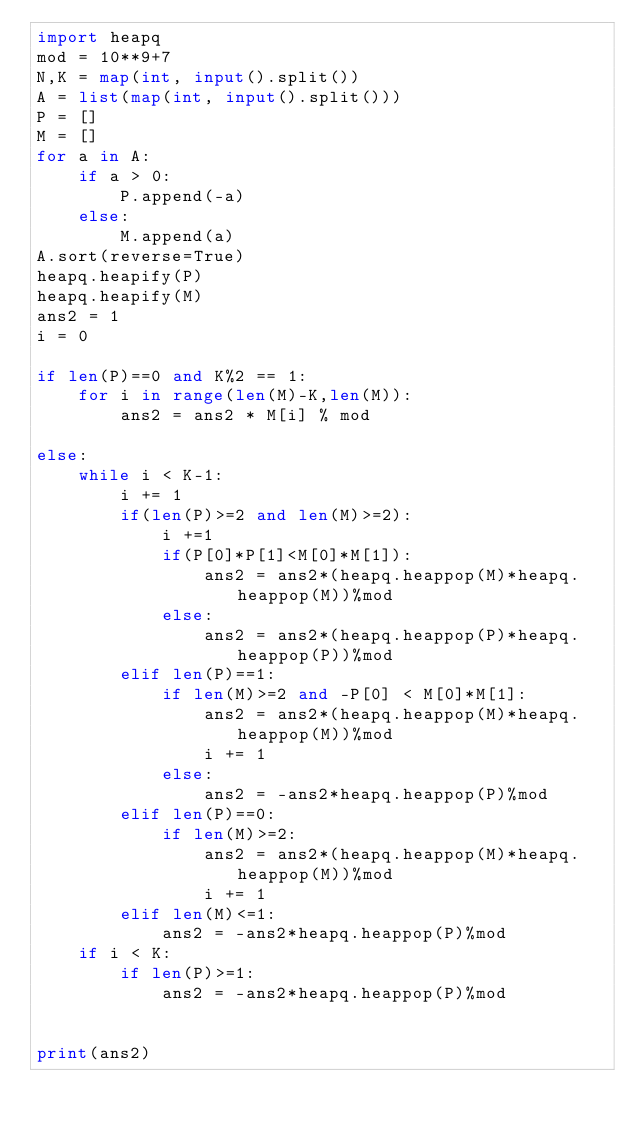Convert code to text. <code><loc_0><loc_0><loc_500><loc_500><_Python_>import heapq
mod = 10**9+7
N,K = map(int, input().split())
A = list(map(int, input().split()))
P = []
M = []
for a in A:
    if a > 0:
        P.append(-a)
    else:
        M.append(a) 
A.sort(reverse=True)
heapq.heapify(P)
heapq.heapify(M)
ans2 = 1
i = 0

if len(P)==0 and K%2 == 1:
    for i in range(len(M)-K,len(M)):
        ans2 = ans2 * M[i] % mod 

else:
    while i < K-1:
        i += 1
        if(len(P)>=2 and len(M)>=2):
            i +=1
            if(P[0]*P[1]<M[0]*M[1]):
                ans2 = ans2*(heapq.heappop(M)*heapq.heappop(M))%mod
            else:
                ans2 = ans2*(heapq.heappop(P)*heapq.heappop(P))%mod
        elif len(P)==1:
            if len(M)>=2 and -P[0] < M[0]*M[1]:
                ans2 = ans2*(heapq.heappop(M)*heapq.heappop(M))%mod
                i += 1
            else:
                ans2 = -ans2*heapq.heappop(P)%mod
        elif len(P)==0:
            if len(M)>=2:
                ans2 = ans2*(heapq.heappop(M)*heapq.heappop(M))%mod
                i += 1
        elif len(M)<=1:
            ans2 = -ans2*heapq.heappop(P)%mod
    if i < K:
        if len(P)>=1:
            ans2 = -ans2*heapq.heappop(P)%mod


print(ans2)</code> 